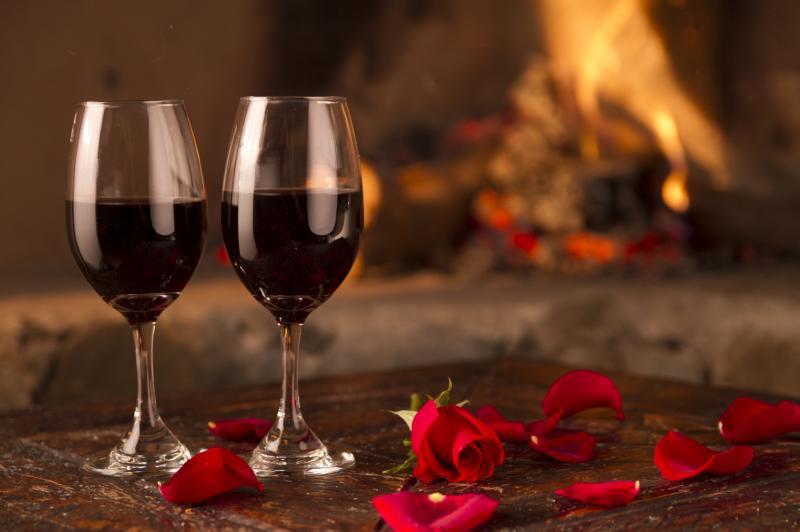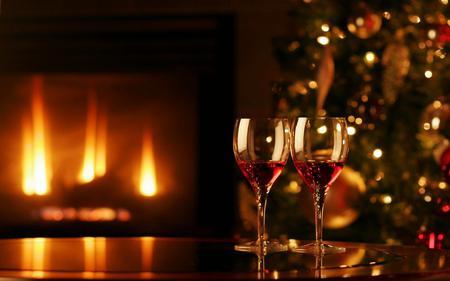The first image is the image on the left, the second image is the image on the right. Considering the images on both sides, is "there are four wine glasses total in both" valid? Answer yes or no. Yes. The first image is the image on the left, the second image is the image on the right. Analyze the images presented: Is the assertion "There is an obvious fireplace in the background of one of the images." valid? Answer yes or no. Yes. 